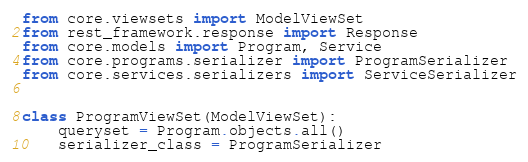Convert code to text. <code><loc_0><loc_0><loc_500><loc_500><_Python_>from core.viewsets import ModelViewSet
from rest_framework.response import Response
from core.models import Program, Service
from core.programs.serializer import ProgramSerializer
from core.services.serializers import ServiceSerializer


class ProgramViewSet(ModelViewSet):
    queryset = Program.objects.all()
    serializer_class = ProgramSerializer
</code> 